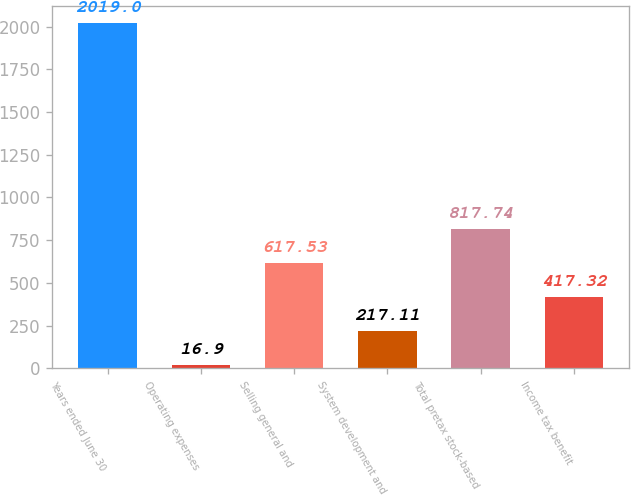<chart> <loc_0><loc_0><loc_500><loc_500><bar_chart><fcel>Years ended June 30<fcel>Operating expenses<fcel>Selling general and<fcel>System development and<fcel>Total pretax stock-based<fcel>Income tax benefit<nl><fcel>2019<fcel>16.9<fcel>617.53<fcel>217.11<fcel>817.74<fcel>417.32<nl></chart> 